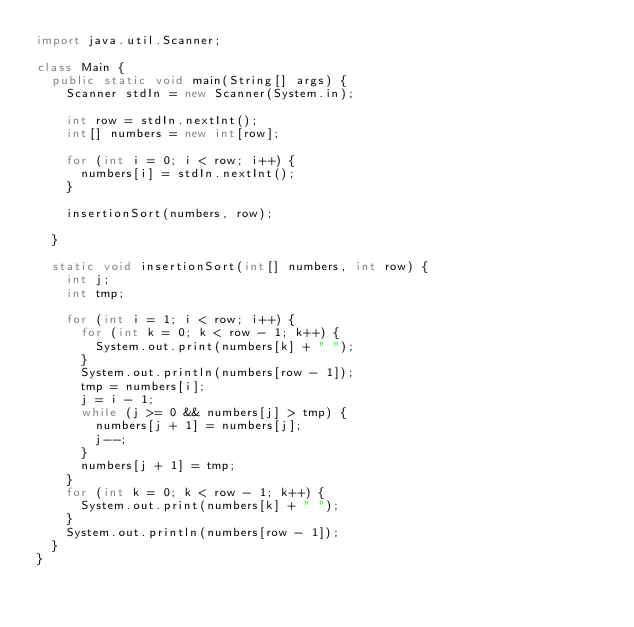<code> <loc_0><loc_0><loc_500><loc_500><_Java_>import java.util.Scanner;

class Main {
	public static void main(String[] args) {
		Scanner stdIn = new Scanner(System.in);

		int row = stdIn.nextInt();
		int[] numbers = new int[row];

		for (int i = 0; i < row; i++) {
			numbers[i] = stdIn.nextInt();
		}

		insertionSort(numbers, row);

	}

	static void insertionSort(int[] numbers, int row) {
		int j;
		int tmp;

		for (int i = 1; i < row; i++) {
			for (int k = 0; k < row - 1; k++) {
				System.out.print(numbers[k] + " ");
			}
			System.out.println(numbers[row - 1]);
			tmp = numbers[i];
			j = i - 1;
			while (j >= 0 && numbers[j] > tmp) {
				numbers[j + 1] = numbers[j];
				j--;
			}
			numbers[j + 1] = tmp;
		}
		for (int k = 0; k < row - 1; k++) {
			System.out.print(numbers[k] + " ");
		}
		System.out.println(numbers[row - 1]);
	}
}</code> 